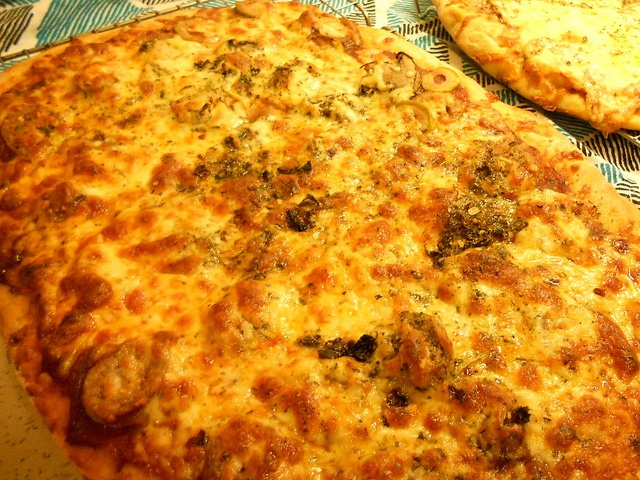Describe the objects in this image and their specific colors. I can see pizza in orange, red, olive, and gold tones and pizza in olive, khaki, orange, and red tones in this image. 